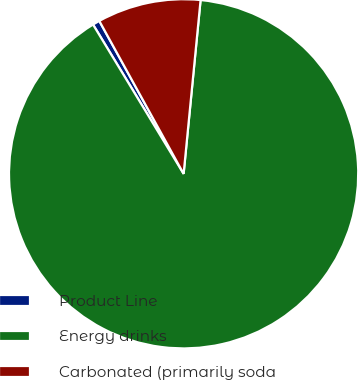<chart> <loc_0><loc_0><loc_500><loc_500><pie_chart><fcel>Product Line<fcel>Energy drinks<fcel>Carbonated (primarily soda<nl><fcel>0.66%<fcel>89.77%<fcel>9.57%<nl></chart> 